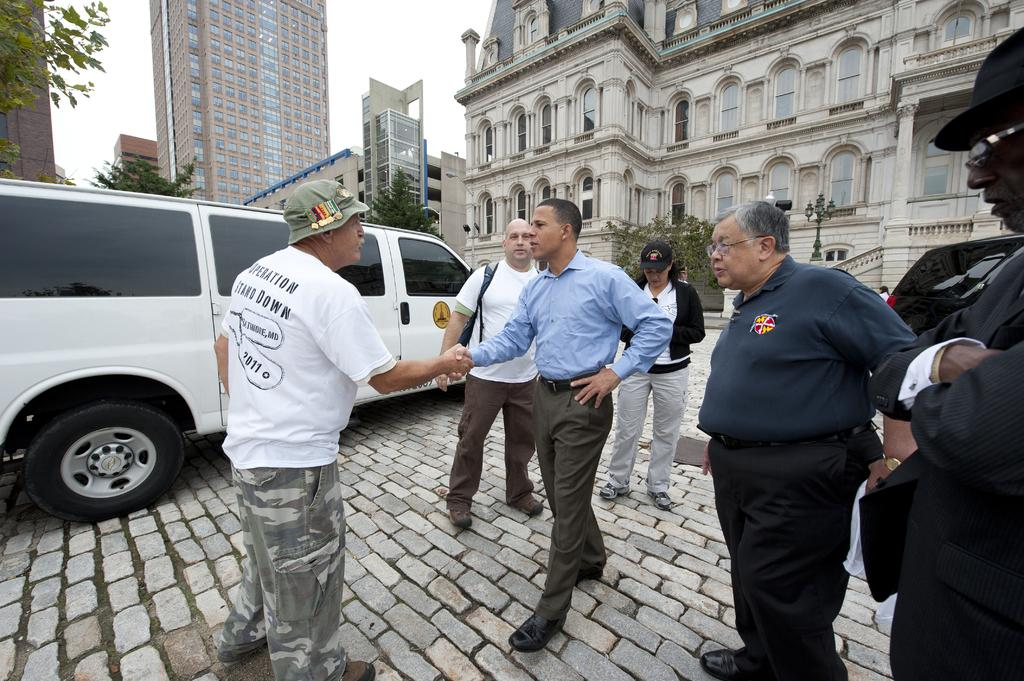What are the people in the image doing? The people in the image are standing on the ground. What else can be seen in the image besides the people? There are vehicles, trees, light poles, buildings, and the sky visible in the image. Can you describe the background of the image? The background of the image includes trees, light poles, buildings, and the sky. What type of coach is the person thinking about in the image? There is no coach or indication of thought in the image; it only shows people standing on the ground and other elements in the background. 